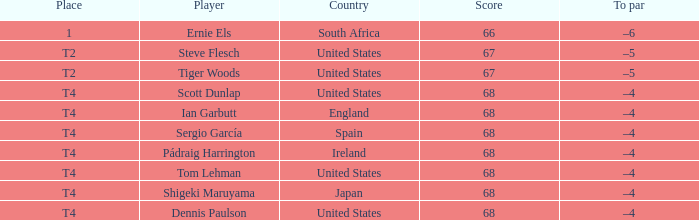What is T2 Place Player Steve Flesch's Score? 67.0. 